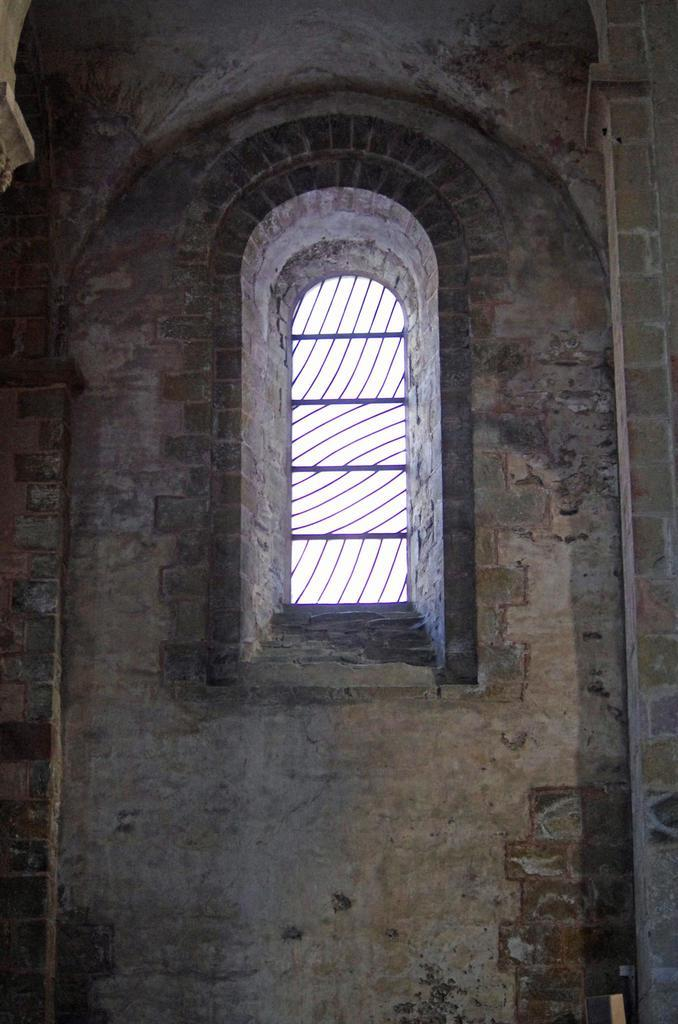What type of structure can be seen in the image? There is a wall in the image. What feature is present in the wall? There is a window in the image. What type of cast can be seen on the wall in the image? There is no cast present on the wall in the image. Can you describe the wave pattern on the wall in the image? There is no wave pattern on the wall in the image. 